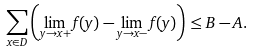<formula> <loc_0><loc_0><loc_500><loc_500>\sum _ { x \in D } \left ( \lim _ { y \to x + } f ( y ) - \lim _ { y \to x - } f ( y ) \right ) \leq B - A .</formula> 